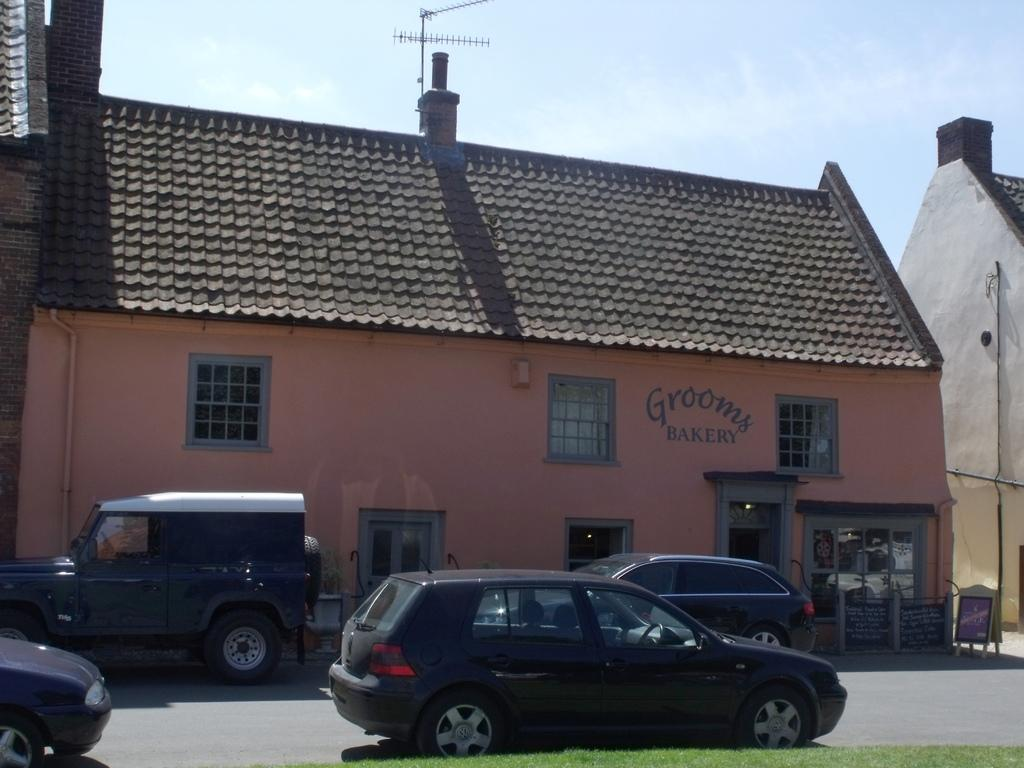What type of vehicles can be seen in the image? There are cars in the image. What structure is present in the image? There is a house in the image. What feature can be observed on the house? The house has windows. What is visible at the top of the image? The sky is visible at the top of the image. What type of knee can be seen in the image? There is no knee present in the image. What type of produce is being picked in the image? There is no produce or pickling activity depicted in the image. 